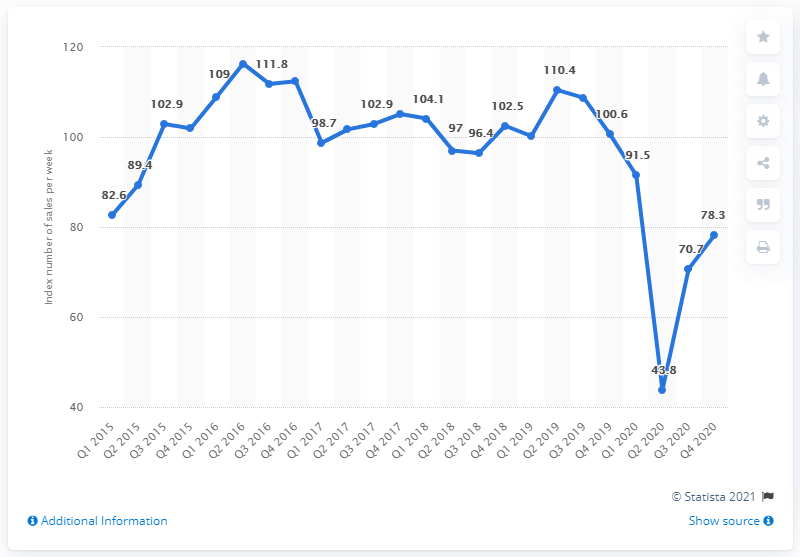Give some essential details in this illustration. In the second quarter of 2020, the sales volume of computers and telecoms was 43.8.. In the last quarter of 2020, the index value for computers and telecoms was 78.3. 